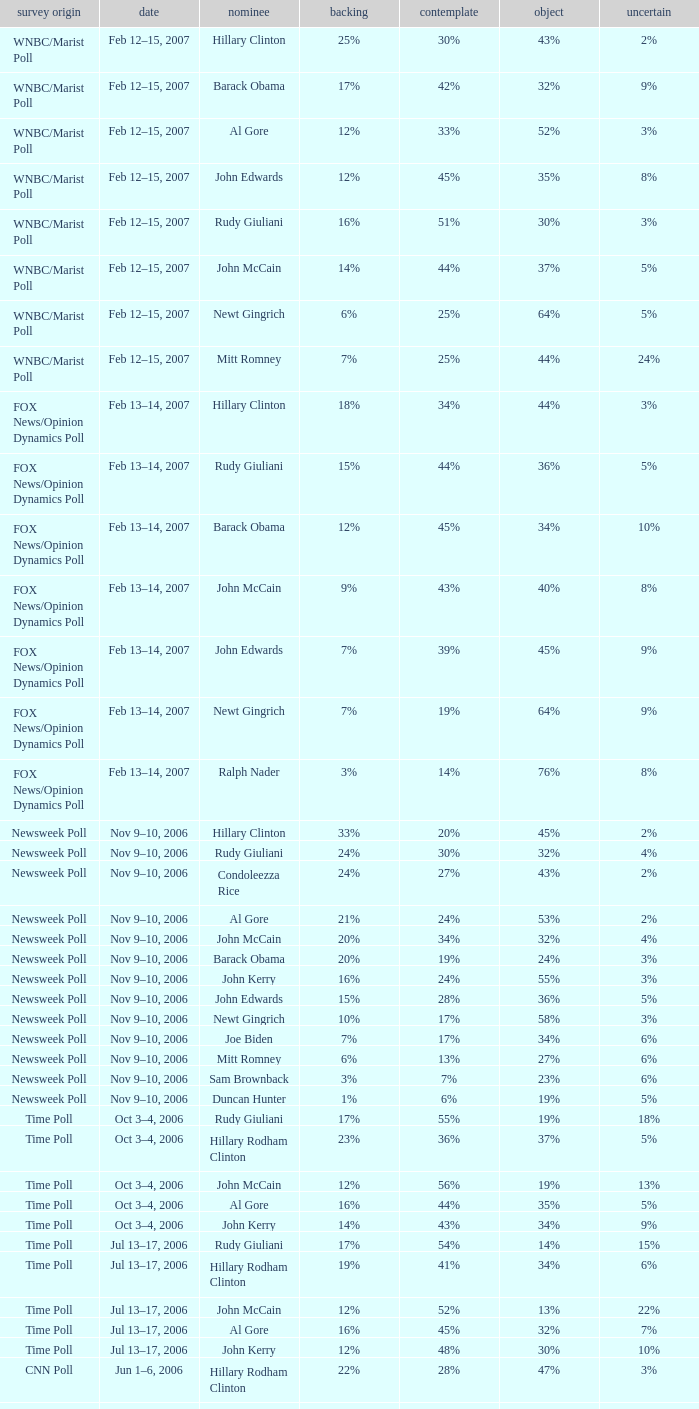What percentage of people were opposed to the candidate based on the Time Poll poll that showed 6% of people were unsure? 34%. Could you parse the entire table as a dict? {'header': ['survey origin', 'date', 'nominee', 'backing', 'contemplate', 'object', 'uncertain'], 'rows': [['WNBC/Marist Poll', 'Feb 12–15, 2007', 'Hillary Clinton', '25%', '30%', '43%', '2%'], ['WNBC/Marist Poll', 'Feb 12–15, 2007', 'Barack Obama', '17%', '42%', '32%', '9%'], ['WNBC/Marist Poll', 'Feb 12–15, 2007', 'Al Gore', '12%', '33%', '52%', '3%'], ['WNBC/Marist Poll', 'Feb 12–15, 2007', 'John Edwards', '12%', '45%', '35%', '8%'], ['WNBC/Marist Poll', 'Feb 12–15, 2007', 'Rudy Giuliani', '16%', '51%', '30%', '3%'], ['WNBC/Marist Poll', 'Feb 12–15, 2007', 'John McCain', '14%', '44%', '37%', '5%'], ['WNBC/Marist Poll', 'Feb 12–15, 2007', 'Newt Gingrich', '6%', '25%', '64%', '5%'], ['WNBC/Marist Poll', 'Feb 12–15, 2007', 'Mitt Romney', '7%', '25%', '44%', '24%'], ['FOX News/Opinion Dynamics Poll', 'Feb 13–14, 2007', 'Hillary Clinton', '18%', '34%', '44%', '3%'], ['FOX News/Opinion Dynamics Poll', 'Feb 13–14, 2007', 'Rudy Giuliani', '15%', '44%', '36%', '5%'], ['FOX News/Opinion Dynamics Poll', 'Feb 13–14, 2007', 'Barack Obama', '12%', '45%', '34%', '10%'], ['FOX News/Opinion Dynamics Poll', 'Feb 13–14, 2007', 'John McCain', '9%', '43%', '40%', '8%'], ['FOX News/Opinion Dynamics Poll', 'Feb 13–14, 2007', 'John Edwards', '7%', '39%', '45%', '9%'], ['FOX News/Opinion Dynamics Poll', 'Feb 13–14, 2007', 'Newt Gingrich', '7%', '19%', '64%', '9%'], ['FOX News/Opinion Dynamics Poll', 'Feb 13–14, 2007', 'Ralph Nader', '3%', '14%', '76%', '8%'], ['Newsweek Poll', 'Nov 9–10, 2006', 'Hillary Clinton', '33%', '20%', '45%', '2%'], ['Newsweek Poll', 'Nov 9–10, 2006', 'Rudy Giuliani', '24%', '30%', '32%', '4%'], ['Newsweek Poll', 'Nov 9–10, 2006', 'Condoleezza Rice', '24%', '27%', '43%', '2%'], ['Newsweek Poll', 'Nov 9–10, 2006', 'Al Gore', '21%', '24%', '53%', '2%'], ['Newsweek Poll', 'Nov 9–10, 2006', 'John McCain', '20%', '34%', '32%', '4%'], ['Newsweek Poll', 'Nov 9–10, 2006', 'Barack Obama', '20%', '19%', '24%', '3%'], ['Newsweek Poll', 'Nov 9–10, 2006', 'John Kerry', '16%', '24%', '55%', '3%'], ['Newsweek Poll', 'Nov 9–10, 2006', 'John Edwards', '15%', '28%', '36%', '5%'], ['Newsweek Poll', 'Nov 9–10, 2006', 'Newt Gingrich', '10%', '17%', '58%', '3%'], ['Newsweek Poll', 'Nov 9–10, 2006', 'Joe Biden', '7%', '17%', '34%', '6%'], ['Newsweek Poll', 'Nov 9–10, 2006', 'Mitt Romney', '6%', '13%', '27%', '6%'], ['Newsweek Poll', 'Nov 9–10, 2006', 'Sam Brownback', '3%', '7%', '23%', '6%'], ['Newsweek Poll', 'Nov 9–10, 2006', 'Duncan Hunter', '1%', '6%', '19%', '5%'], ['Time Poll', 'Oct 3–4, 2006', 'Rudy Giuliani', '17%', '55%', '19%', '18%'], ['Time Poll', 'Oct 3–4, 2006', 'Hillary Rodham Clinton', '23%', '36%', '37%', '5%'], ['Time Poll', 'Oct 3–4, 2006', 'John McCain', '12%', '56%', '19%', '13%'], ['Time Poll', 'Oct 3–4, 2006', 'Al Gore', '16%', '44%', '35%', '5%'], ['Time Poll', 'Oct 3–4, 2006', 'John Kerry', '14%', '43%', '34%', '9%'], ['Time Poll', 'Jul 13–17, 2006', 'Rudy Giuliani', '17%', '54%', '14%', '15%'], ['Time Poll', 'Jul 13–17, 2006', 'Hillary Rodham Clinton', '19%', '41%', '34%', '6%'], ['Time Poll', 'Jul 13–17, 2006', 'John McCain', '12%', '52%', '13%', '22%'], ['Time Poll', 'Jul 13–17, 2006', 'Al Gore', '16%', '45%', '32%', '7%'], ['Time Poll', 'Jul 13–17, 2006', 'John Kerry', '12%', '48%', '30%', '10%'], ['CNN Poll', 'Jun 1–6, 2006', 'Hillary Rodham Clinton', '22%', '28%', '47%', '3%'], ['CNN Poll', 'Jun 1–6, 2006', 'Al Gore', '17%', '32%', '48%', '3%'], ['CNN Poll', 'Jun 1–6, 2006', 'John Kerry', '14%', '35%', '47%', '4%'], ['CNN Poll', 'Jun 1–6, 2006', 'Rudolph Giuliani', '19%', '45%', '30%', '6%'], ['CNN Poll', 'Jun 1–6, 2006', 'John McCain', '12%', '48%', '34%', '6%'], ['CNN Poll', 'Jun 1–6, 2006', 'Jeb Bush', '9%', '26%', '63%', '2%'], ['ABC News/Washington Post Poll', 'May 11–15, 2006', 'Hillary Clinton', '19%', '38%', '42%', '1%'], ['ABC News/Washington Post Poll', 'May 11–15, 2006', 'John McCain', '9%', '57%', '28%', '6%'], ['FOX News/Opinion Dynamics Poll', 'Feb 7–8, 2006', 'Hillary Clinton', '35%', '19%', '44%', '2%'], ['FOX News/Opinion Dynamics Poll', 'Feb 7–8, 2006', 'Rudy Giuliani', '33%', '38%', '24%', '6%'], ['FOX News/Opinion Dynamics Poll', 'Feb 7–8, 2006', 'John McCain', '30%', '40%', '22%', '7%'], ['FOX News/Opinion Dynamics Poll', 'Feb 7–8, 2006', 'John Kerry', '29%', '23%', '45%', '3%'], ['FOX News/Opinion Dynamics Poll', 'Feb 7–8, 2006', 'Condoleezza Rice', '14%', '38%', '46%', '3%'], ['CNN/USA Today/Gallup Poll', 'Jan 20–22, 2006', 'Hillary Rodham Clinton', '16%', '32%', '51%', '1%'], ['Diageo/Hotline Poll', 'Nov 11–15, 2005', 'John McCain', '23%', '46%', '15%', '15%'], ['CNN/USA Today/Gallup Poll', 'May 20–22, 2005', 'Hillary Rodham Clinton', '28%', '31%', '40%', '1%'], ['CNN/USA Today/Gallup Poll', 'Jun 9–10, 2003', 'Hillary Rodham Clinton', '20%', '33%', '45%', '2%']]} 